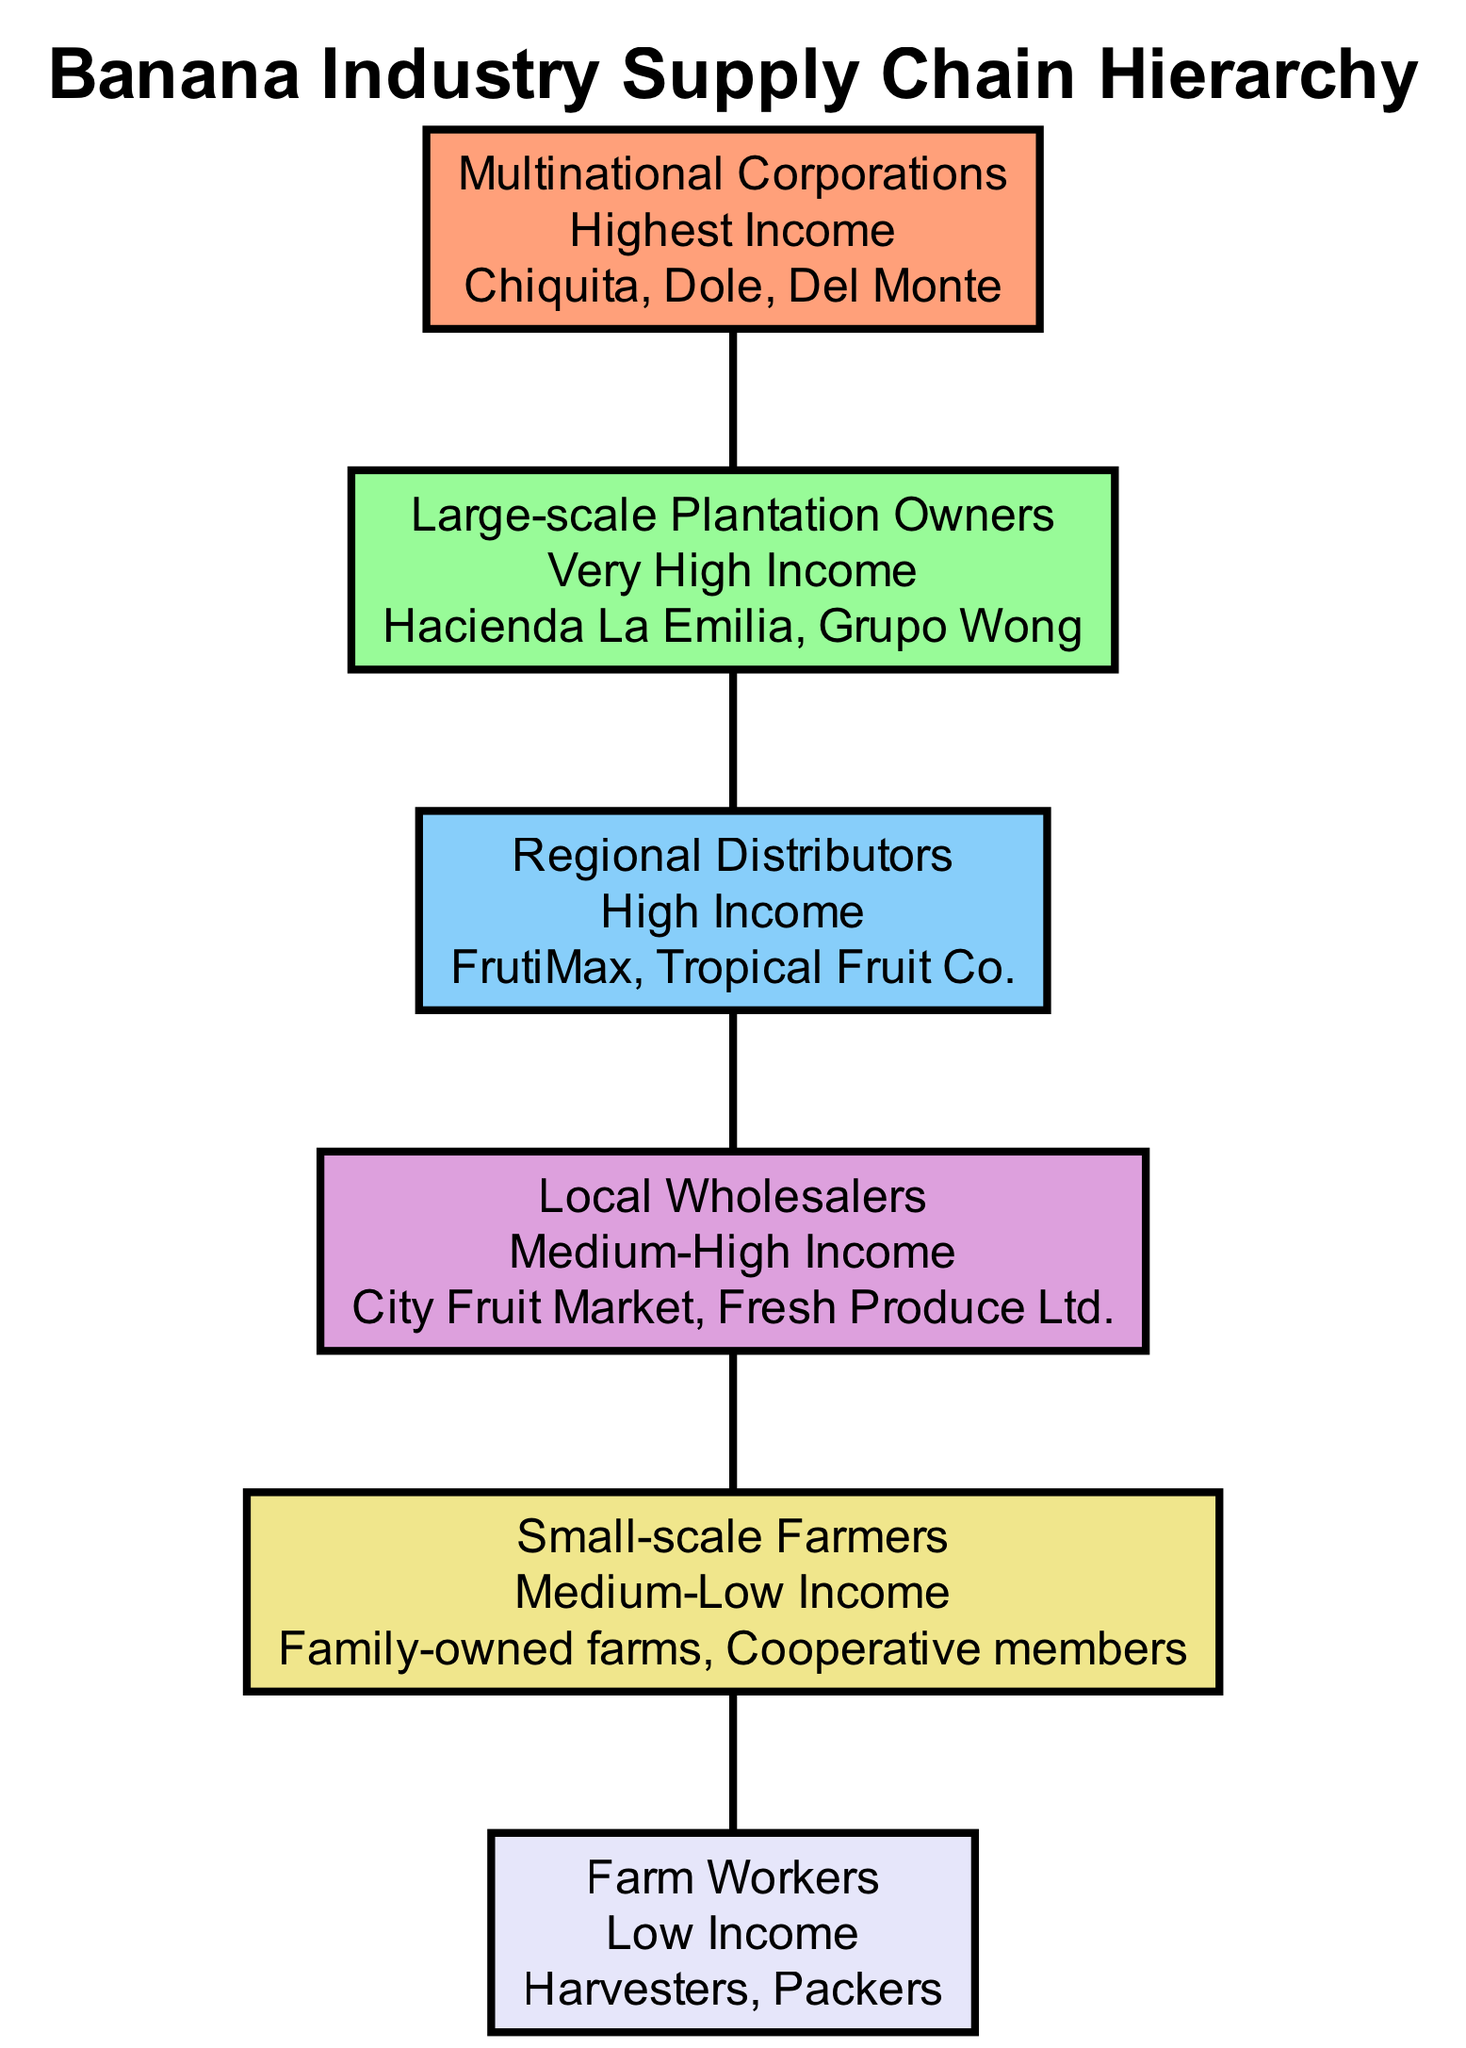What is the highest income level in the diagram? The diagram clearly states that "Multinational Corporations" are at the top level of the hierarchy, indicating that this group has the highest income level.
Answer: Highest How many levels are depicted in the diagram? By counting the different sections marked with distinct roles, there are a total of 6 levels represented in the hierarchy.
Answer: 6 Who are the small-scale farmers characterized by? The section for "Small-scale Farmers" mentions "Family-owned farms" and "Cooperative members" as examples, indicating these types of farming operations are defined as small-scale.
Answer: Family-owned farms, Cooperative members What is the income level of Regional Distributors? The "Regional Distributors" level explicitly indicates its income classification as "High."
Answer: High Which level comes just above Local Wholesalers? The positioning in the hierarchy shows that "Regional Distributors" is directly above "Local Wholesalers."
Answer: Regional Distributors What group represents the lowest income level in the pyramid? The diagram specifies that "Farm Workers" are located at the bottom of the pyramid with a "Low" income designation, making them the lowest income level in this hierarchy.
Answer: Farm Workers List the examples for Large-scale Plantation Owners. Within the "Large-scale Plantation Owners" level, the diagram provides examples including "Hacienda La Emilia" and "Grupo Wong," which are the specific identifiers for this group.
Answer: Hacienda La Emilia, Grupo Wong What color represents the "Small-scale Farmers" level in the diagram? The colors have been assigned to each level, and "Small-scale Farmers" is depicted using a light yellow shade, which can be identified directly in the visual representation of that level.
Answer: Light yellow What relationship is depicted between Regional Distributors and Multinational Corporations? The diagram shows that Regional Distributors are positioned below Multinational Corporations, indicating a hierarchical structure where Multinational Corporations are above Regional Distributors in the supply chain.
Answer: Hierarchical structure 